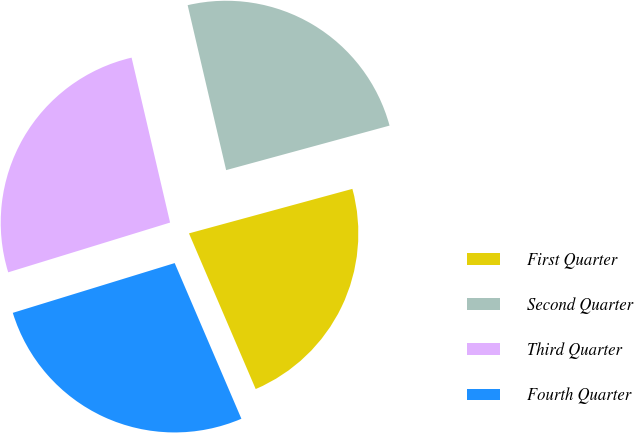Convert chart. <chart><loc_0><loc_0><loc_500><loc_500><pie_chart><fcel>First Quarter<fcel>Second Quarter<fcel>Third Quarter<fcel>Fourth Quarter<nl><fcel>22.79%<fcel>24.42%<fcel>26.1%<fcel>26.7%<nl></chart> 